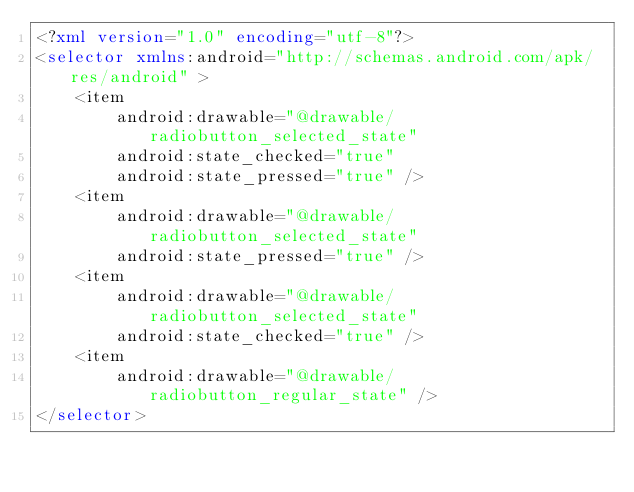<code> <loc_0><loc_0><loc_500><loc_500><_XML_><?xml version="1.0" encoding="utf-8"?>
<selector xmlns:android="http://schemas.android.com/apk/res/android" >
    <item
        android:drawable="@drawable/radiobutton_selected_state"
        android:state_checked="true"
        android:state_pressed="true" />
    <item
        android:drawable="@drawable/radiobutton_selected_state"
        android:state_pressed="true" />
    <item
        android:drawable="@drawable/radiobutton_selected_state"
        android:state_checked="true" />
    <item
        android:drawable="@drawable/radiobutton_regular_state" />
</selector></code> 